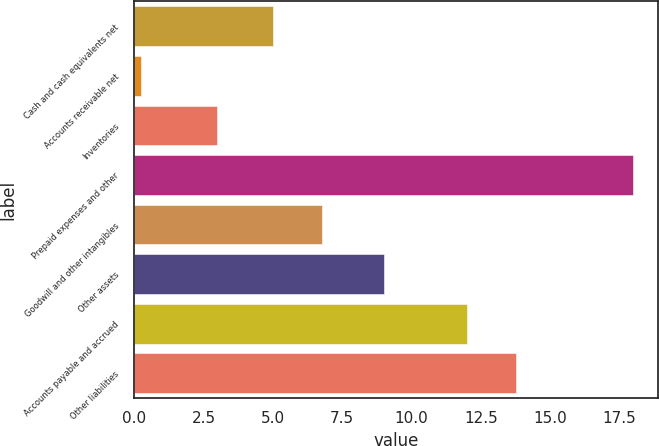Convert chart. <chart><loc_0><loc_0><loc_500><loc_500><bar_chart><fcel>Cash and cash equivalents net<fcel>Accounts receivable net<fcel>Inventories<fcel>Prepaid expenses and other<fcel>Goodwill and other intangibles<fcel>Other assets<fcel>Accounts payable and accrued<fcel>Other liabilities<nl><fcel>5<fcel>0.26<fcel>3<fcel>18<fcel>6.77<fcel>9<fcel>12<fcel>13.77<nl></chart> 